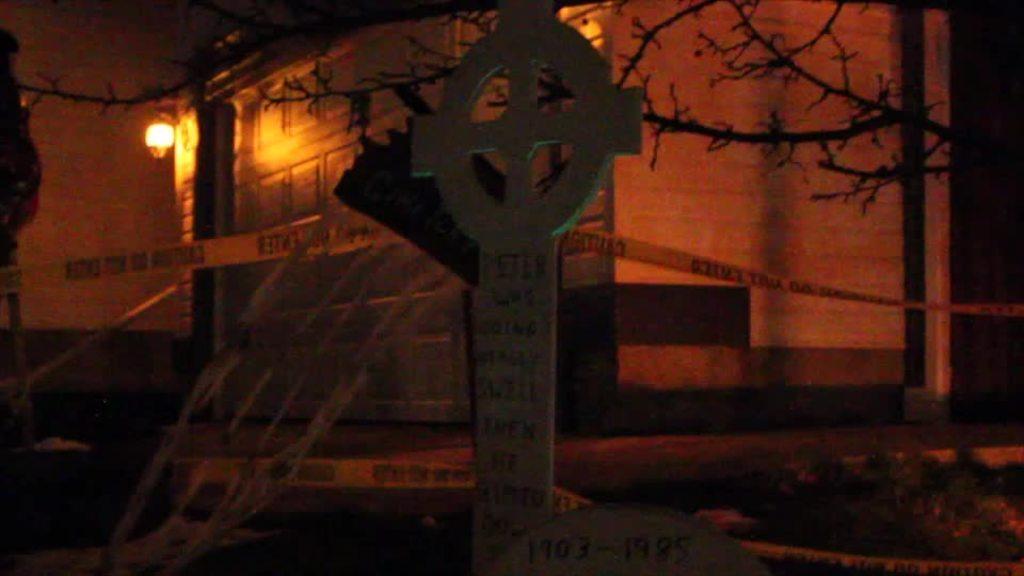Please provide a concise description of this image. There is a symbol, fence, dry tree branches and a building which has a light at the left. 